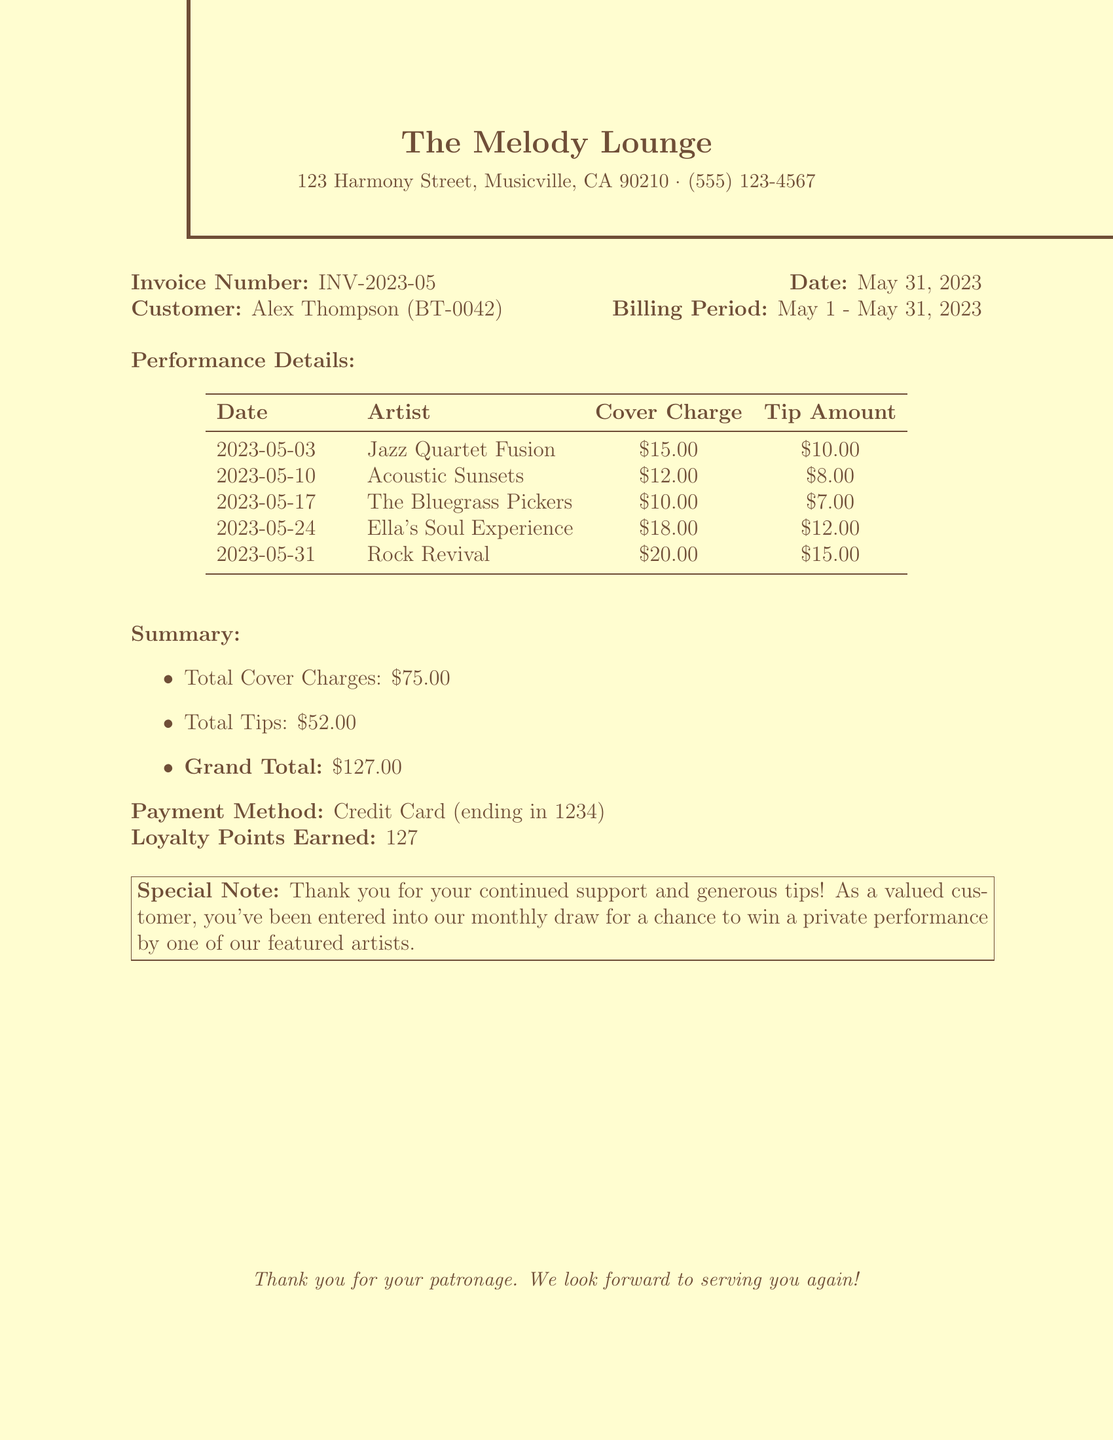What is the venue name? The venue name is listed prominently at the top of the document.
Answer: The Melody Lounge What is the customer ID? The customer ID is specified next to the customer name in the invoice details.
Answer: BT-0042 What date does this invoice cover? The billing period outlines the start and end date for the invoice coverage.
Answer: May 1 - May 31, 2023 How much was the cover charge for Rock Revival? The cover charge for each performance is detailed in the performance table.
Answer: $20.00 What is the total amount of tips given? The total tips are summarized at the end of the performance details.
Answer: $52.00 How many loyalty points were earned? The loyalty points earned are specified in the summary section of the invoice.
Answer: 127 What is the payment method used? The payment method is indicated in the summary at the bottom of the invoice.
Answer: Credit Card (ending in 1234) Which artist performed on May 10, 2023? The artist for each performance is listed alongside the corresponding date in the performance table.
Answer: Acoustic Sunsets What was the total cover charge for the performances? The total cover charges are calculated in the summary section of the document.
Answer: $75.00 